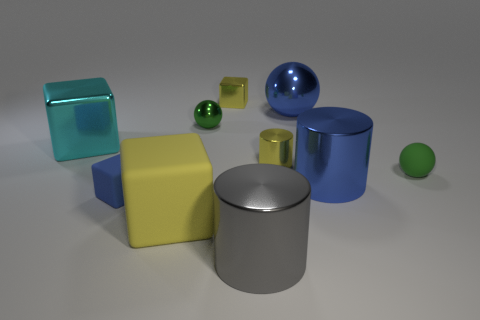Subtract all red cubes. Subtract all blue cylinders. How many cubes are left? 4 Subtract all blocks. How many objects are left? 6 Subtract all yellow blocks. Subtract all gray metal balls. How many objects are left? 8 Add 1 blue rubber blocks. How many blue rubber blocks are left? 2 Add 2 yellow spheres. How many yellow spheres exist? 2 Subtract 0 red cylinders. How many objects are left? 10 